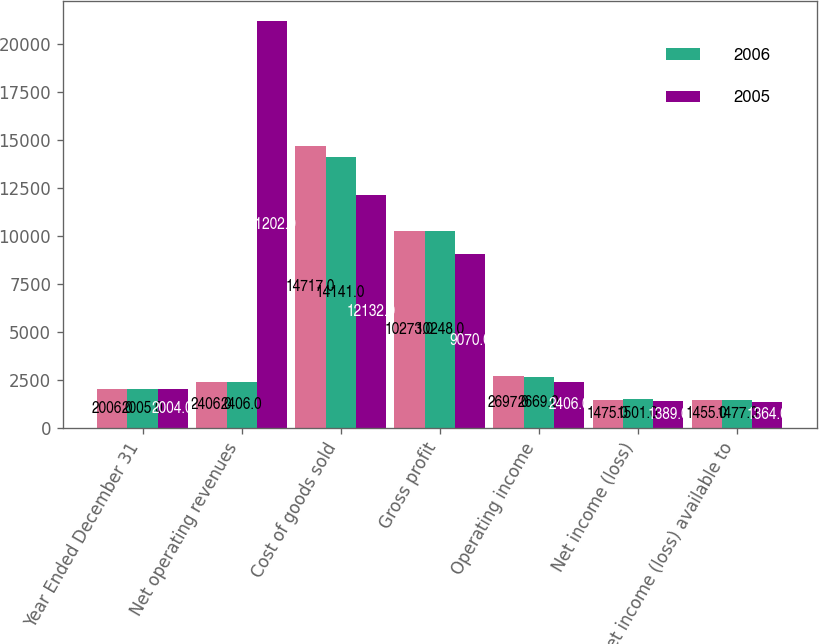<chart> <loc_0><loc_0><loc_500><loc_500><stacked_bar_chart><ecel><fcel>Year Ended December 31<fcel>Net operating revenues<fcel>Cost of goods sold<fcel>Gross profit<fcel>Operating income<fcel>Net income (loss)<fcel>Net income (loss) available to<nl><fcel>nan<fcel>2006<fcel>2406<fcel>14717<fcel>10273<fcel>2697<fcel>1475<fcel>1455<nl><fcel>2006<fcel>2005<fcel>2406<fcel>14141<fcel>10248<fcel>2669<fcel>1501<fcel>1477<nl><fcel>2005<fcel>2004<fcel>21202<fcel>12132<fcel>9070<fcel>2406<fcel>1389<fcel>1364<nl></chart> 